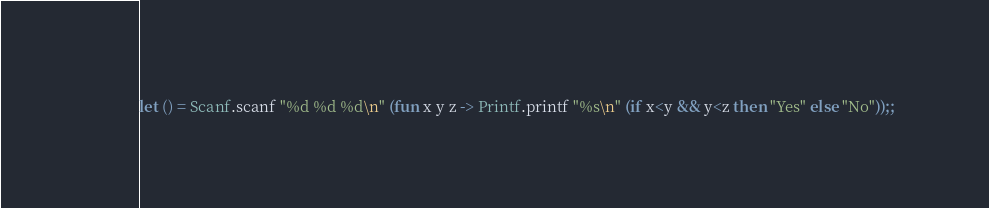Convert code to text. <code><loc_0><loc_0><loc_500><loc_500><_OCaml_>let () = Scanf.scanf "%d %d %d\n" (fun x y z -> Printf.printf "%s\n" (if x<y && y<z then "Yes" else "No"));;</code> 